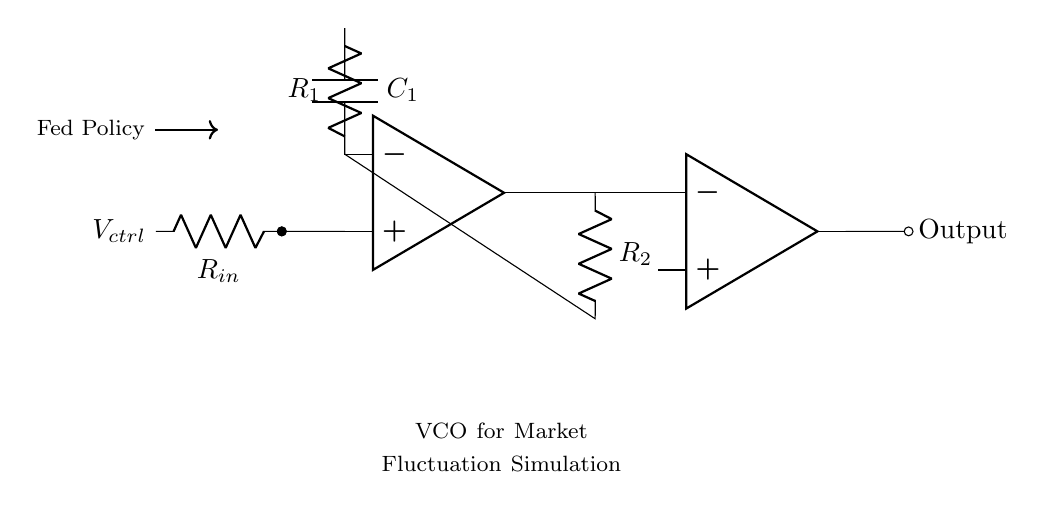What type of circuit is depicted in this diagram? The diagram represents a voltage-controlled oscillator (VCO), which is evident from the operational amplifier configuration and the feedback loop for generating an oscillating output.
Answer: Voltage-controlled oscillator What is the purpose of the control voltage in this circuit? The control voltage, indicated as V_ctrl, adjusts the frequency of the output signal by changing the behavior of the oscillator. The relationships between the control voltage and components determine the oscillation frequency.
Answer: Frequency adjustment How many resistors are present in the circuit? There are three resistors labeled R1, R2, and R_in in the circuit diagram, which are integral to the operation of the voltage-controlled oscillator.
Answer: Three What happens if the value of R1 is increased? Increasing R1 would likely lead to a decrease in the oscillation frequency of the output signal since R1 sets the time constant of the circuit in conjunction with C1.
Answer: Decrease frequency What component is used to buffer the output signal? The circuit employs an operational amplifier as a buffer after the oscillator, ensuring that the output does not load the previous stage and maintains the integrity of the signal.
Answer: Operational amplifier How does Fed policy influence this circuit's output? The Fed policy influences the control voltage (V_ctrl) input, which directly affects the oscillator's frequency, mirroring how economic indicators can impact market fluctuations.
Answer: Influences frequency 